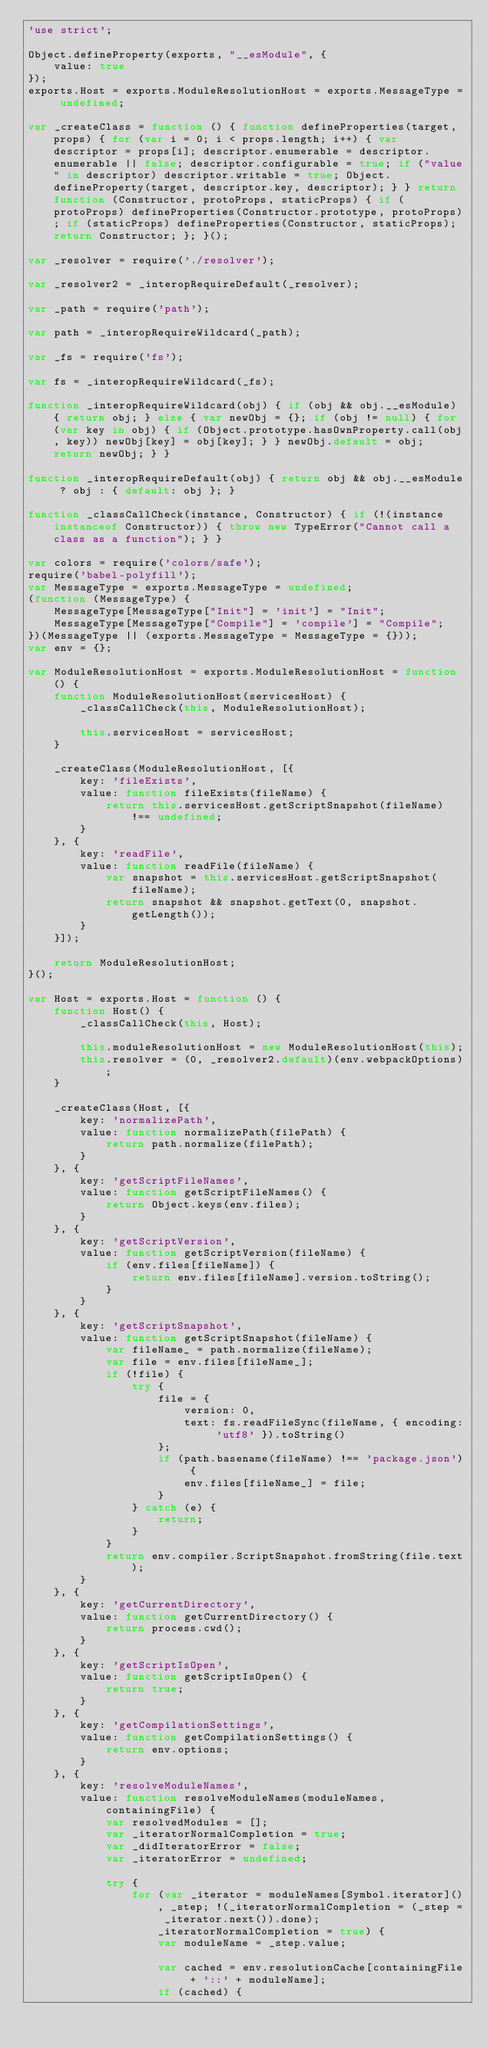<code> <loc_0><loc_0><loc_500><loc_500><_JavaScript_>'use strict';

Object.defineProperty(exports, "__esModule", {
    value: true
});
exports.Host = exports.ModuleResolutionHost = exports.MessageType = undefined;

var _createClass = function () { function defineProperties(target, props) { for (var i = 0; i < props.length; i++) { var descriptor = props[i]; descriptor.enumerable = descriptor.enumerable || false; descriptor.configurable = true; if ("value" in descriptor) descriptor.writable = true; Object.defineProperty(target, descriptor.key, descriptor); } } return function (Constructor, protoProps, staticProps) { if (protoProps) defineProperties(Constructor.prototype, protoProps); if (staticProps) defineProperties(Constructor, staticProps); return Constructor; }; }();

var _resolver = require('./resolver');

var _resolver2 = _interopRequireDefault(_resolver);

var _path = require('path');

var path = _interopRequireWildcard(_path);

var _fs = require('fs');

var fs = _interopRequireWildcard(_fs);

function _interopRequireWildcard(obj) { if (obj && obj.__esModule) { return obj; } else { var newObj = {}; if (obj != null) { for (var key in obj) { if (Object.prototype.hasOwnProperty.call(obj, key)) newObj[key] = obj[key]; } } newObj.default = obj; return newObj; } }

function _interopRequireDefault(obj) { return obj && obj.__esModule ? obj : { default: obj }; }

function _classCallCheck(instance, Constructor) { if (!(instance instanceof Constructor)) { throw new TypeError("Cannot call a class as a function"); } }

var colors = require('colors/safe');
require('babel-polyfill');
var MessageType = exports.MessageType = undefined;
(function (MessageType) {
    MessageType[MessageType["Init"] = 'init'] = "Init";
    MessageType[MessageType["Compile"] = 'compile'] = "Compile";
})(MessageType || (exports.MessageType = MessageType = {}));
var env = {};

var ModuleResolutionHost = exports.ModuleResolutionHost = function () {
    function ModuleResolutionHost(servicesHost) {
        _classCallCheck(this, ModuleResolutionHost);

        this.servicesHost = servicesHost;
    }

    _createClass(ModuleResolutionHost, [{
        key: 'fileExists',
        value: function fileExists(fileName) {
            return this.servicesHost.getScriptSnapshot(fileName) !== undefined;
        }
    }, {
        key: 'readFile',
        value: function readFile(fileName) {
            var snapshot = this.servicesHost.getScriptSnapshot(fileName);
            return snapshot && snapshot.getText(0, snapshot.getLength());
        }
    }]);

    return ModuleResolutionHost;
}();

var Host = exports.Host = function () {
    function Host() {
        _classCallCheck(this, Host);

        this.moduleResolutionHost = new ModuleResolutionHost(this);
        this.resolver = (0, _resolver2.default)(env.webpackOptions);
    }

    _createClass(Host, [{
        key: 'normalizePath',
        value: function normalizePath(filePath) {
            return path.normalize(filePath);
        }
    }, {
        key: 'getScriptFileNames',
        value: function getScriptFileNames() {
            return Object.keys(env.files);
        }
    }, {
        key: 'getScriptVersion',
        value: function getScriptVersion(fileName) {
            if (env.files[fileName]) {
                return env.files[fileName].version.toString();
            }
        }
    }, {
        key: 'getScriptSnapshot',
        value: function getScriptSnapshot(fileName) {
            var fileName_ = path.normalize(fileName);
            var file = env.files[fileName_];
            if (!file) {
                try {
                    file = {
                        version: 0,
                        text: fs.readFileSync(fileName, { encoding: 'utf8' }).toString()
                    };
                    if (path.basename(fileName) !== 'package.json') {
                        env.files[fileName_] = file;
                    }
                } catch (e) {
                    return;
                }
            }
            return env.compiler.ScriptSnapshot.fromString(file.text);
        }
    }, {
        key: 'getCurrentDirectory',
        value: function getCurrentDirectory() {
            return process.cwd();
        }
    }, {
        key: 'getScriptIsOpen',
        value: function getScriptIsOpen() {
            return true;
        }
    }, {
        key: 'getCompilationSettings',
        value: function getCompilationSettings() {
            return env.options;
        }
    }, {
        key: 'resolveModuleNames',
        value: function resolveModuleNames(moduleNames, containingFile) {
            var resolvedModules = [];
            var _iteratorNormalCompletion = true;
            var _didIteratorError = false;
            var _iteratorError = undefined;

            try {
                for (var _iterator = moduleNames[Symbol.iterator](), _step; !(_iteratorNormalCompletion = (_step = _iterator.next()).done); _iteratorNormalCompletion = true) {
                    var moduleName = _step.value;

                    var cached = env.resolutionCache[containingFile + '::' + moduleName];
                    if (cached) {</code> 